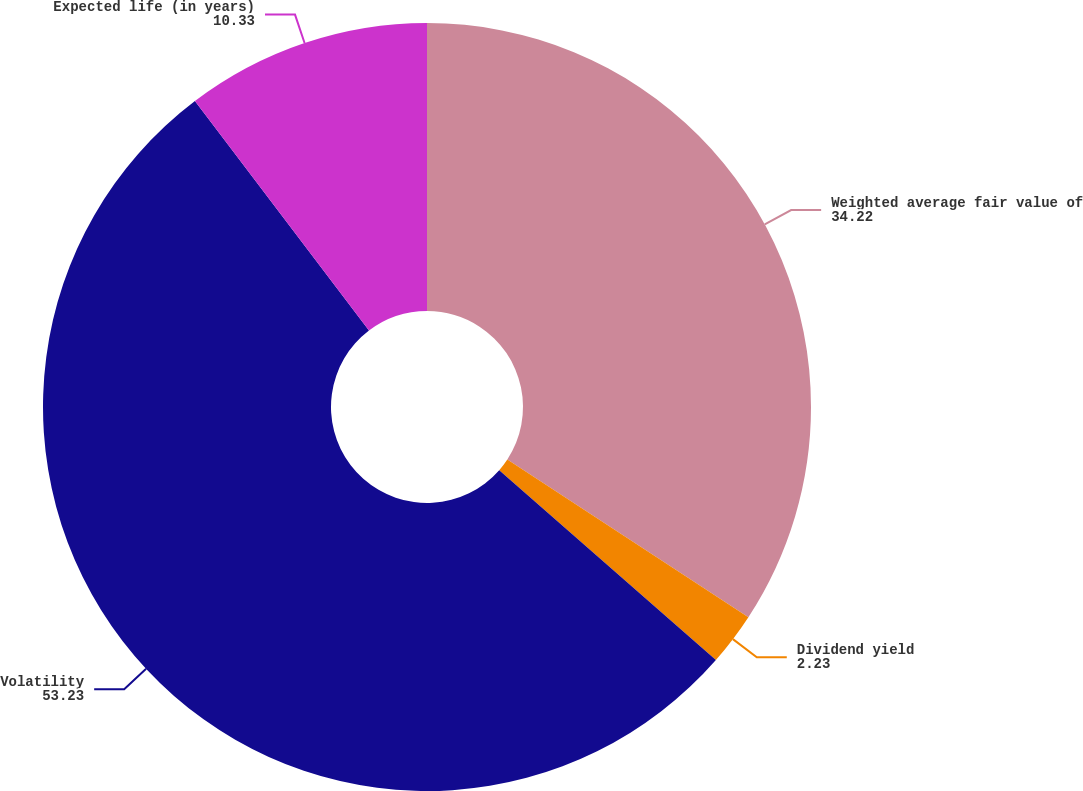Convert chart. <chart><loc_0><loc_0><loc_500><loc_500><pie_chart><fcel>Weighted average fair value of<fcel>Dividend yield<fcel>Volatility<fcel>Expected life (in years)<nl><fcel>34.22%<fcel>2.23%<fcel>53.23%<fcel>10.33%<nl></chart> 